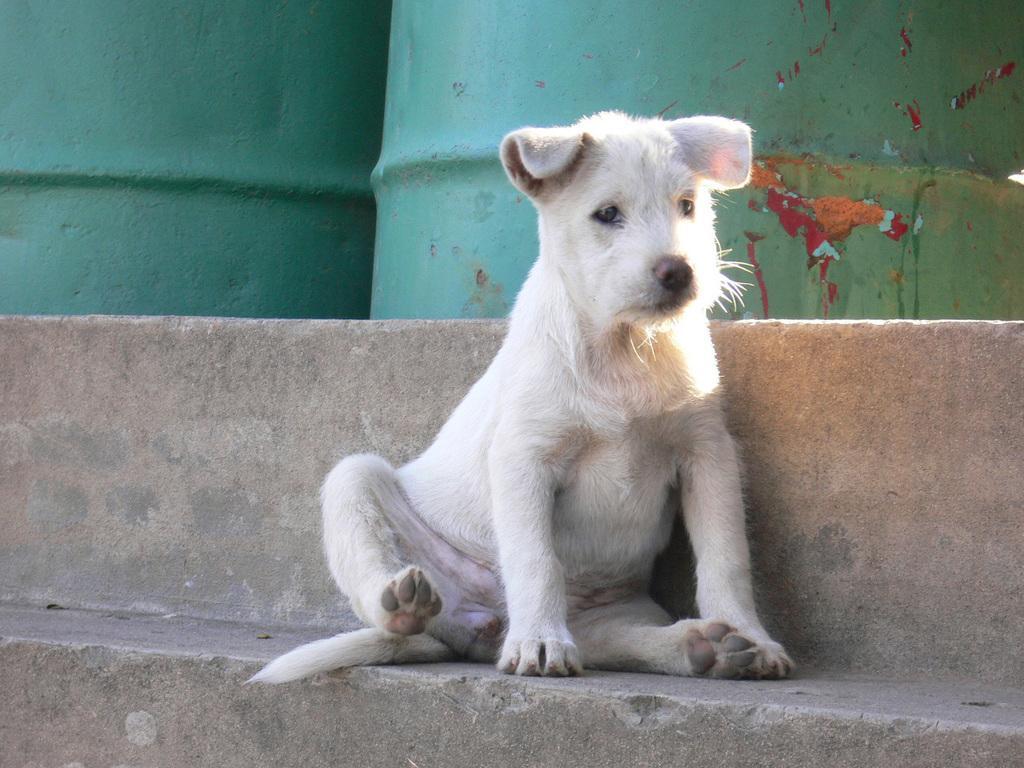Describe this image in one or two sentences. In the center of the image there is a dog sitting on the step. In the background there are barrels. 